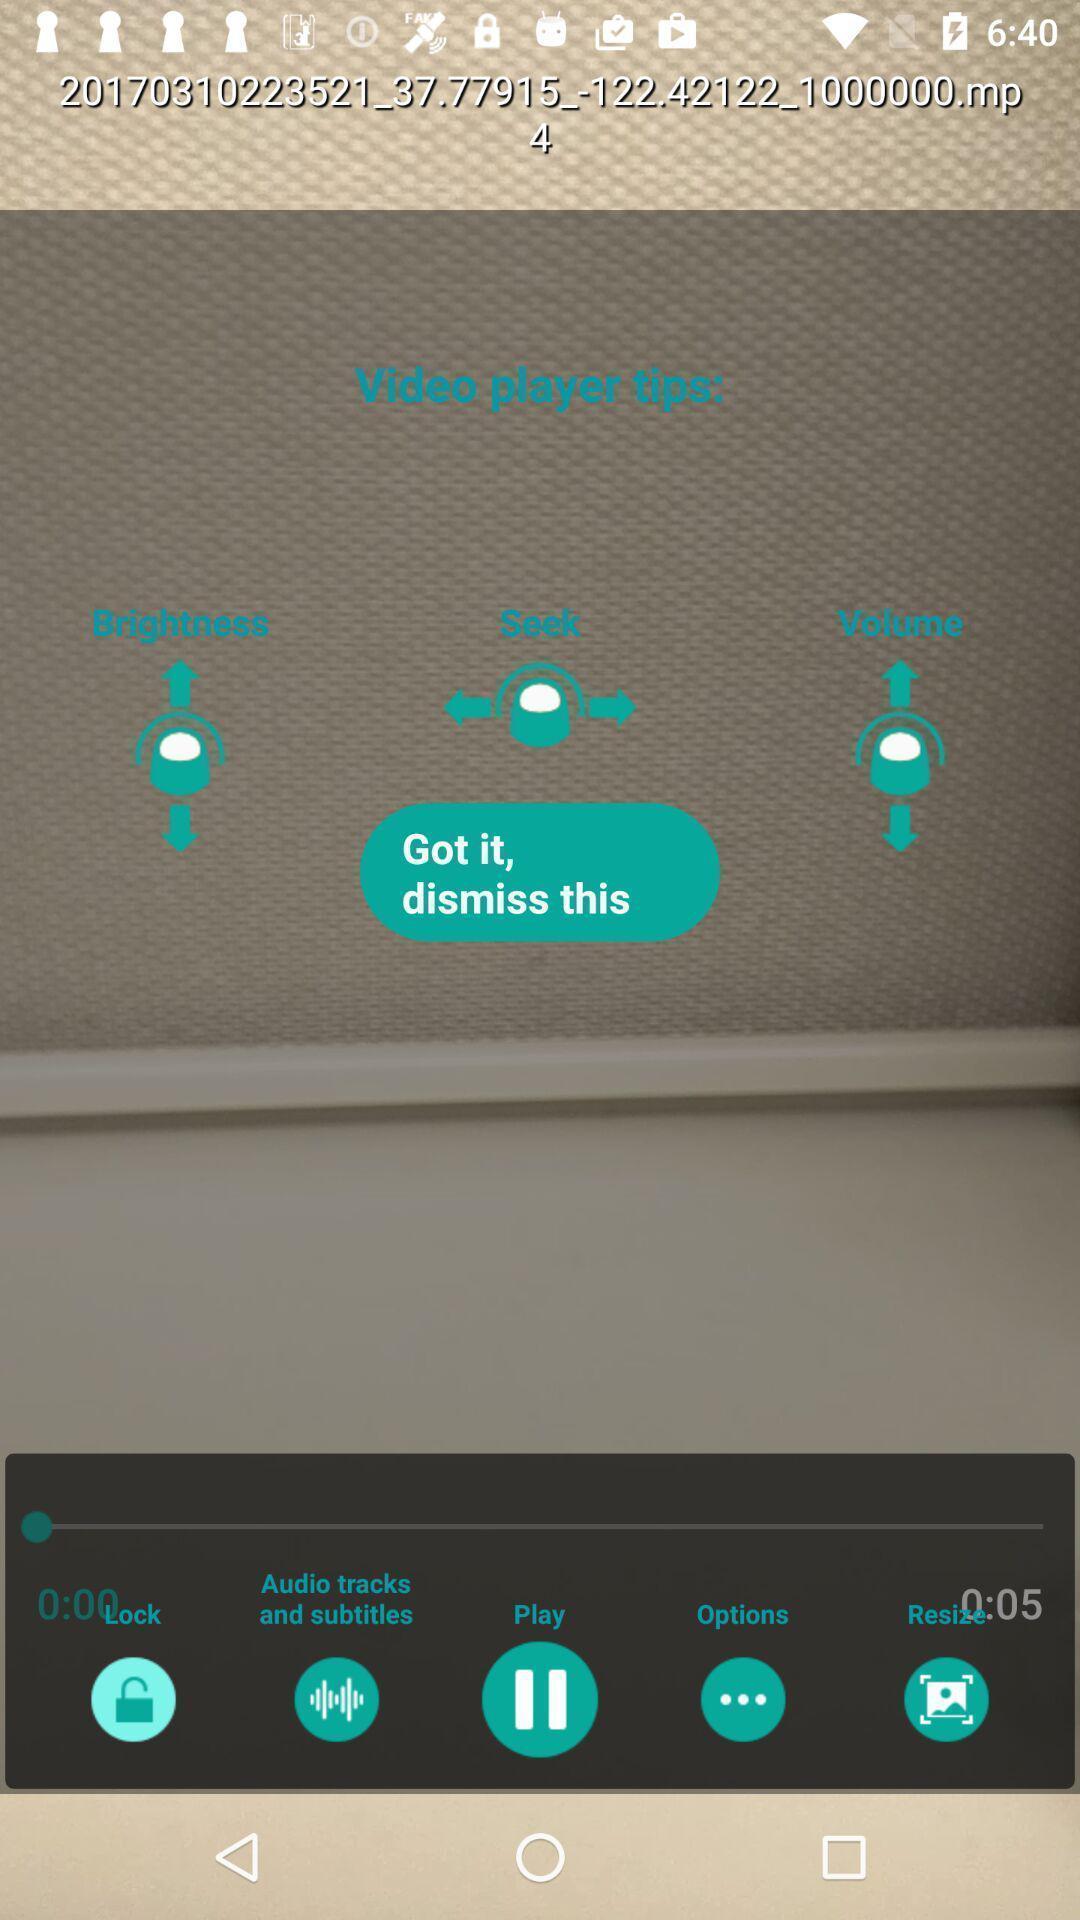Give me a summary of this screen capture. Tips of video player in the video app. 